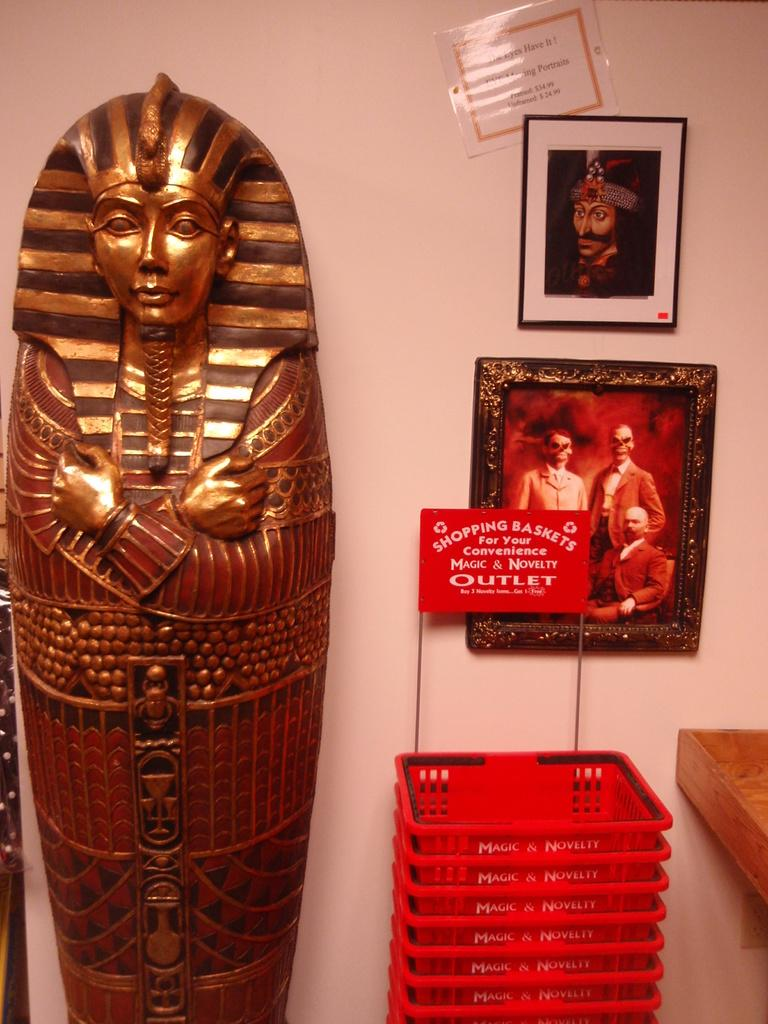What is the main subject in the picture? There is a statue in the picture. What objects are near the statue? There are shopping baskets beside the statue. What can be seen in the background of the picture? There is a wall in the picture. Are there any other statues in the image? Yes, there are statues on the wall. Reasoning: Let' Let's think step by step in order to produce the conversation. We start by identifying the main subject of the image, which is the statue. Then, we describe the objects that are near the statue, which are the shopping baskets. Next, we mention the background of the image, which includes a wall. Finally, we acknowledge the presence of other statues on the wall. Absurd Question/Answer: What type of crime is being committed by the statue in the image? There is no crime being committed by the statue in the image, as it is a stationary object. What is the condition of the trains in the image? There are no trains present in the image. 